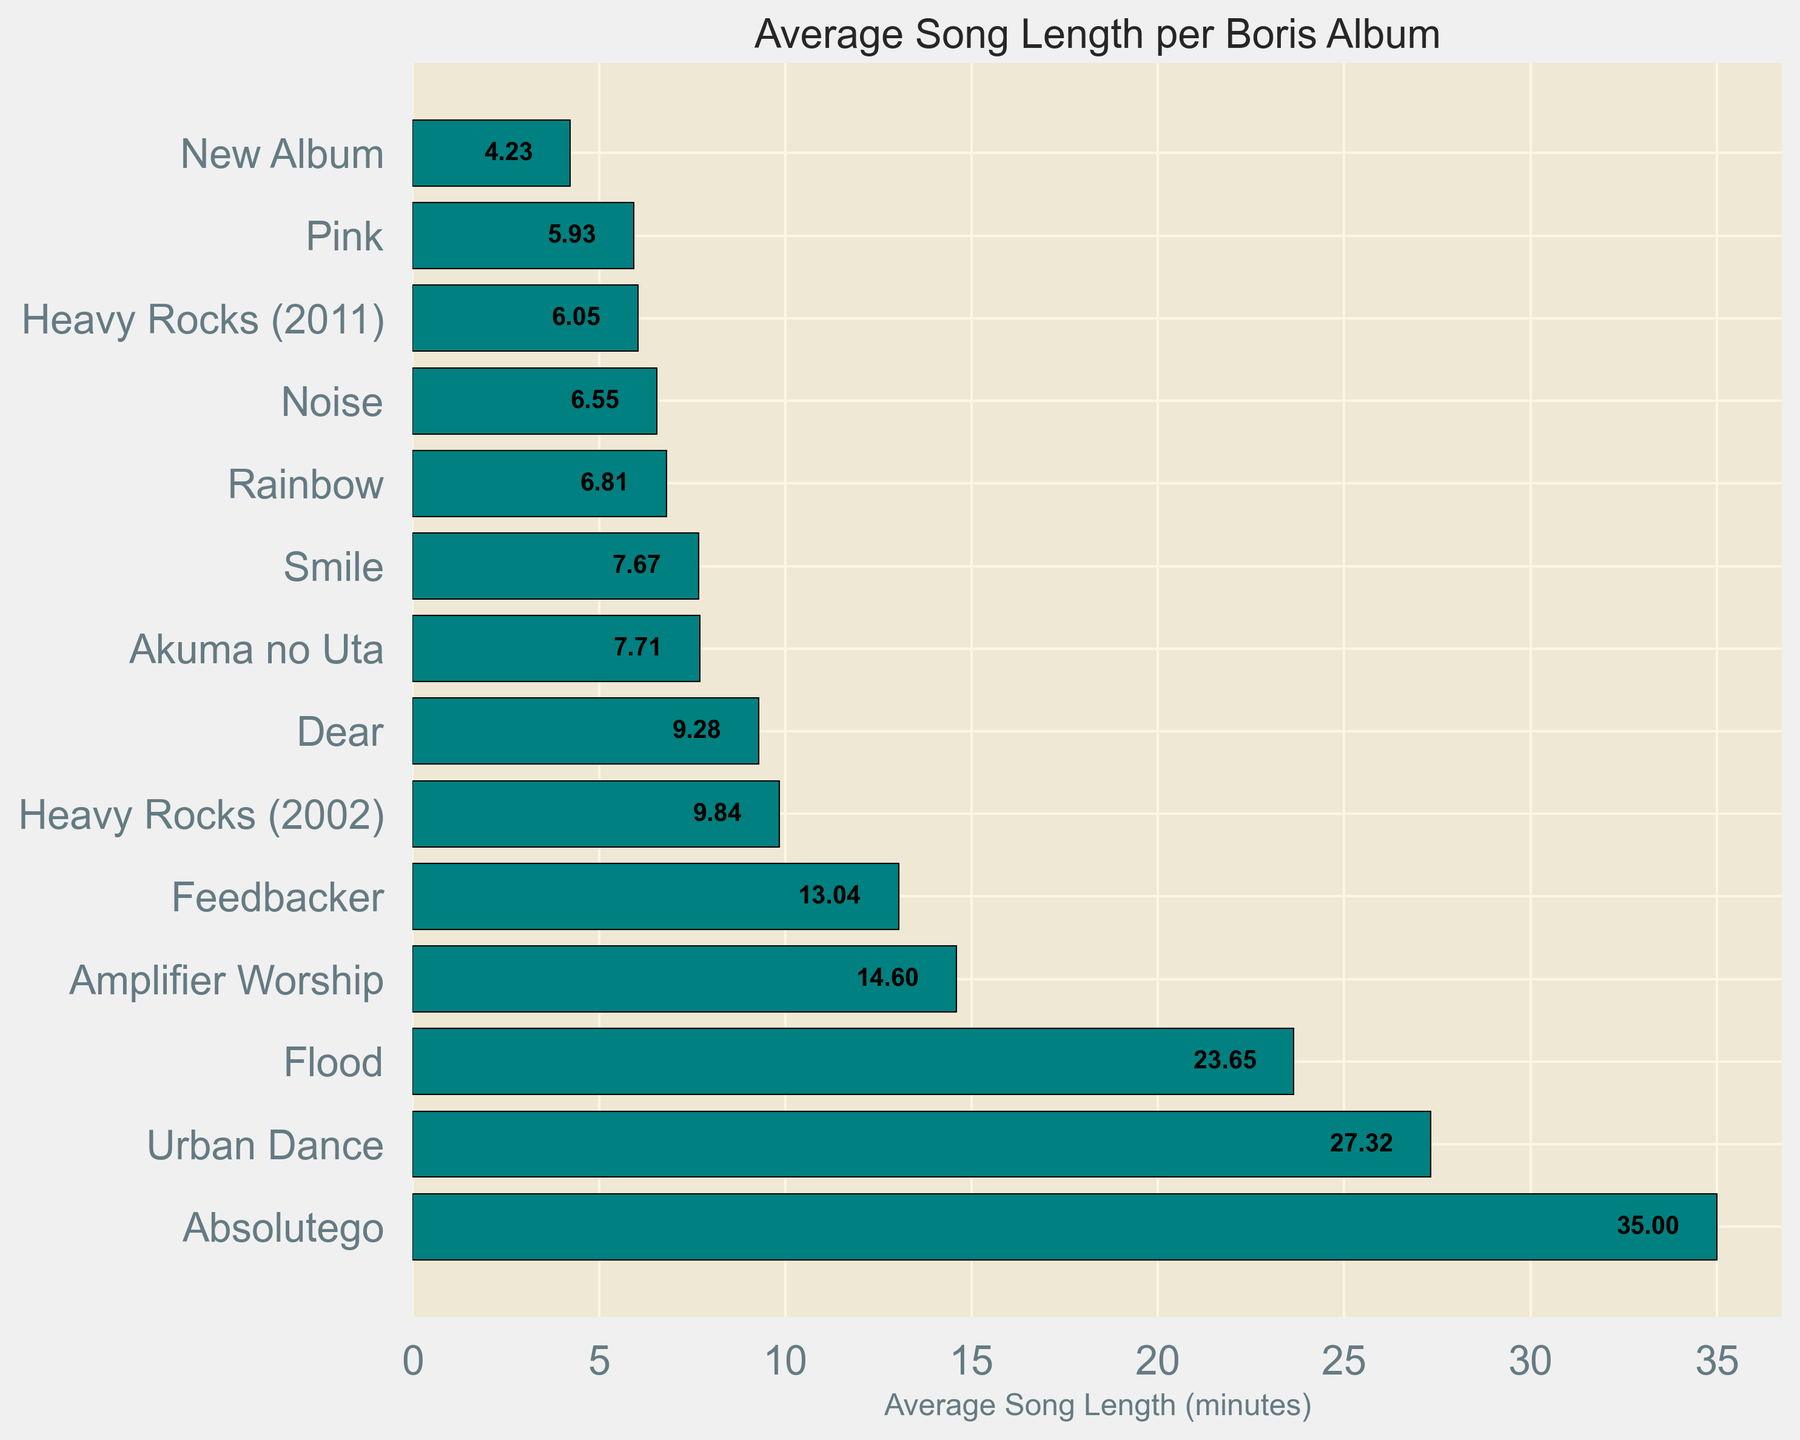Which Boris album has the longest average song length? The bar with the greatest length indicates the album with the longest average song length. "Absolutego" has the longest bar with an average song length of 35 minutes.
Answer: Absolutego Which album ranks second in terms of average song length? After "Absolutego," the next longest bar corresponds to "Urban Dance," with an average song length of 27.32 minutes.
Answer: Urban Dance What is the combined average song length for "Amplifier Worship" and "Flood"? The average song lengths for these albums are "14.60" and "23.65" respectively. Adding these lengths gives 14.60 + 23.65 = 38.25.
Answer: 38.25 Is "Noise" shorter in terms of average song length than "Heavy Rocks (2011)"? By comparing the bar lengths of "Noise" and "Heavy Rocks (2011)," we see that "Noise" has an average of 6.55 minutes whereas "Heavy Rocks (2011)" has 6.05 minutes. Therefore, "Noise" has a longer average song length.
Answer: No How many Boris albums have an average song length greater than 10 minutes? The albums with bars extending beyond the 10-minute mark are "Absolutego," "Urban Dance," "Flood," "Amplifier Worship," and "Feedbacker." Count these bars to find there are five such albums.
Answer: 5 Which album has a marginally shorter average song length than "Akuma no Uta"? "Akuma no Uta" has an average song length of 7.71 minutes. The bar directly below it is "Smile," which has an average length of 7.67 minutes, making it marginally shorter.
Answer: Smile Are the average song lengths of "Pink" and "New Album" closer to each other than to any other album? The average song lengths for "Pink" and "New Album" are 5.93 and 4.23 minutes respectively, giving a difference of 1.70 minutes. Comparing these differences with those of adjacent albums, it appears that other adjacent bars have larger differences.
Answer: Yes Which album has nearly twice the average song length of "New Album"? "New Album" has an average song length of 4.23 minutes. "Heavy Rocks (2011)" has an average song length of 6.05 minutes, which is roughly 1.5 times but not twice. However, no bar exactly doubles 4.23 minutes, making "Heavy Rocks (2011)" the closest.
Answer: Heavy Rocks (2011) 